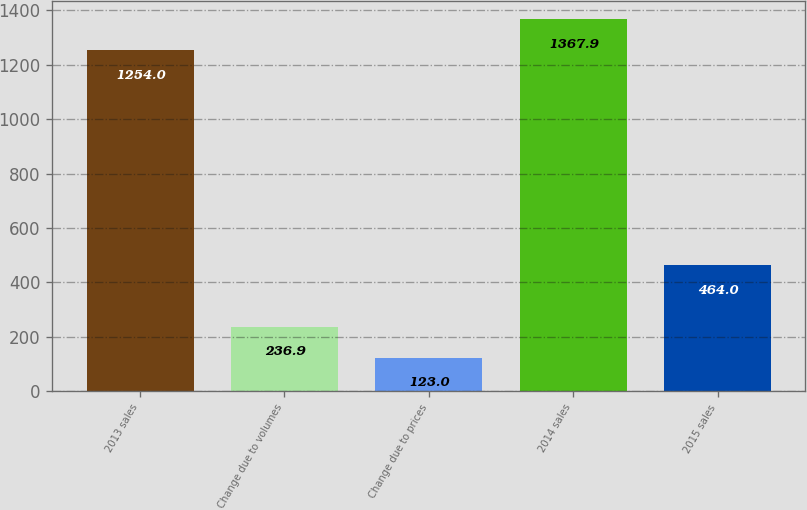Convert chart to OTSL. <chart><loc_0><loc_0><loc_500><loc_500><bar_chart><fcel>2013 sales<fcel>Change due to volumes<fcel>Change due to prices<fcel>2014 sales<fcel>2015 sales<nl><fcel>1254<fcel>236.9<fcel>123<fcel>1367.9<fcel>464<nl></chart> 